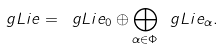Convert formula to latex. <formula><loc_0><loc_0><loc_500><loc_500>\ g L i e = \ g L i e _ { 0 } \oplus \bigoplus _ { \alpha \in \Phi } \ g L i e _ { \alpha } .</formula> 